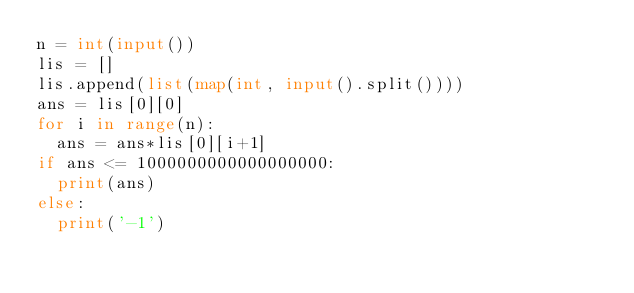<code> <loc_0><loc_0><loc_500><loc_500><_Python_>n = int(input())
lis = []
lis.append(list(map(int, input().split())))
ans = lis[0][0]
for i in range(n):
  ans = ans*lis[0][i+1]
if ans <= 1000000000000000000:
  print(ans)
else:
  print('-1')</code> 